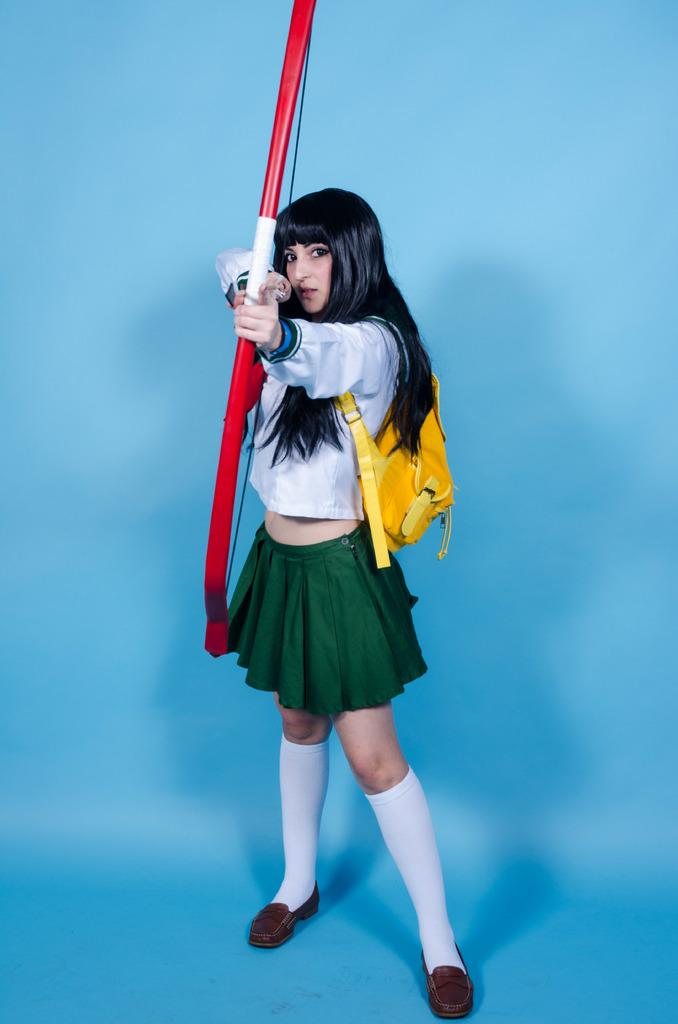Who is the main subject in the image? There is a woman in the image. What is the woman wearing? The woman is wearing a white dress. What accessory is the woman holding in the image? The woman is holding a yellow handbag. What object is the woman holding in addition to the handbag? The woman is holding a bow. What type of music can be heard playing in the background of the image? There is no music present in the image, as it is a still photograph of a woman holding a bow and a handbag. 